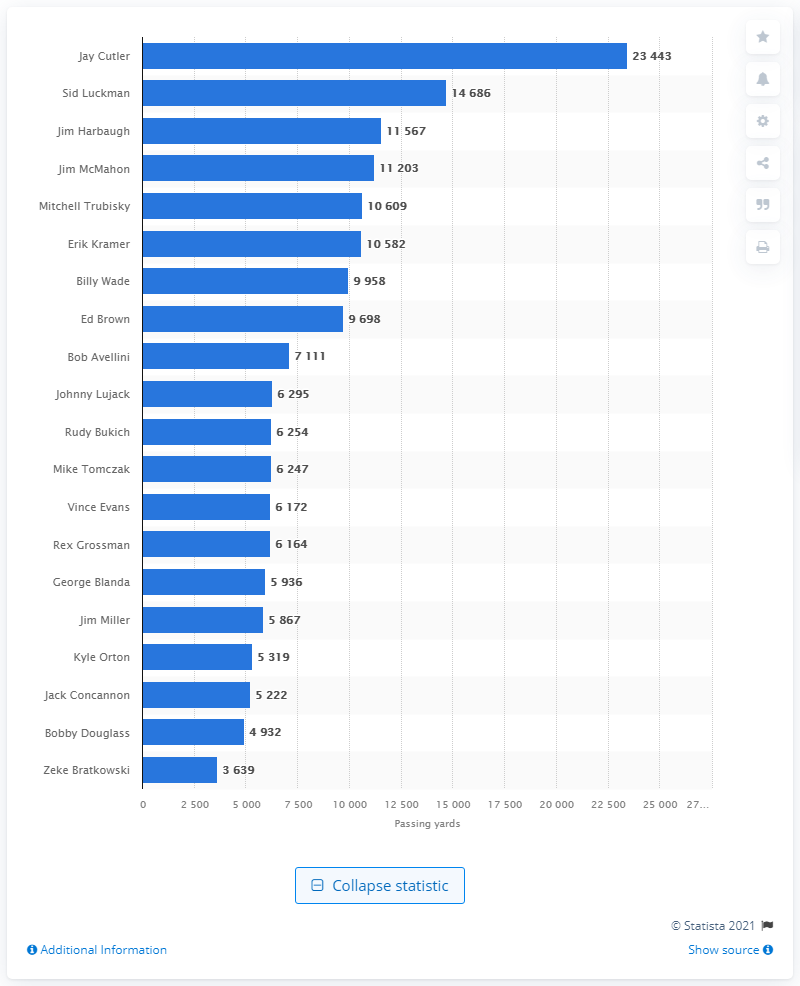Give some essential details in this illustration. Jay Cutler is the career passing leader of the Chicago Bears. 